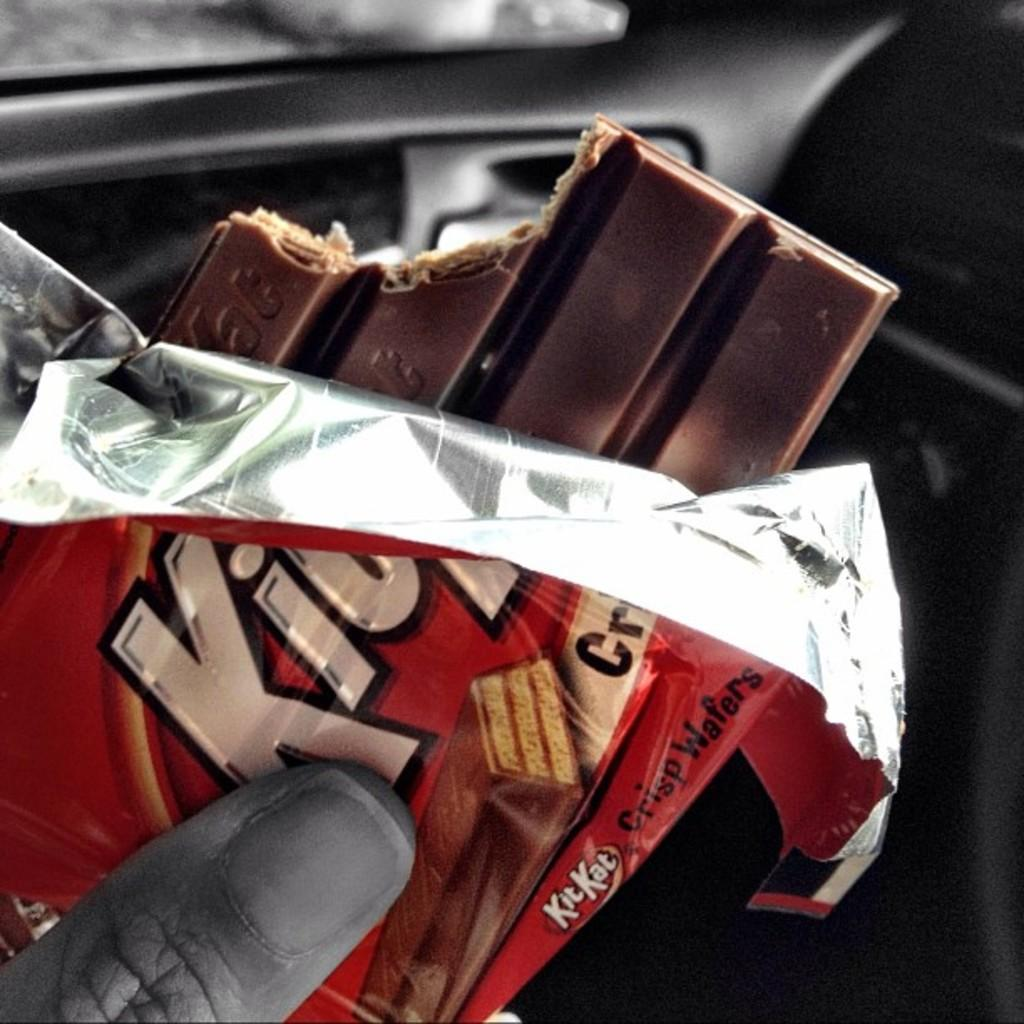What is the main subject of the image? There is a person in the image. What is the person holding in the image? The person is holding a KitKat chocolate. What design is visible on the oven in the image? There is no oven present in the image; it features a person holding a KitKat chocolate. How many times has the person crushed the KitKat chocolate in the image? The image does not show any indication of the KitKat chocolate being crushed, so it cannot be determined from the image. 